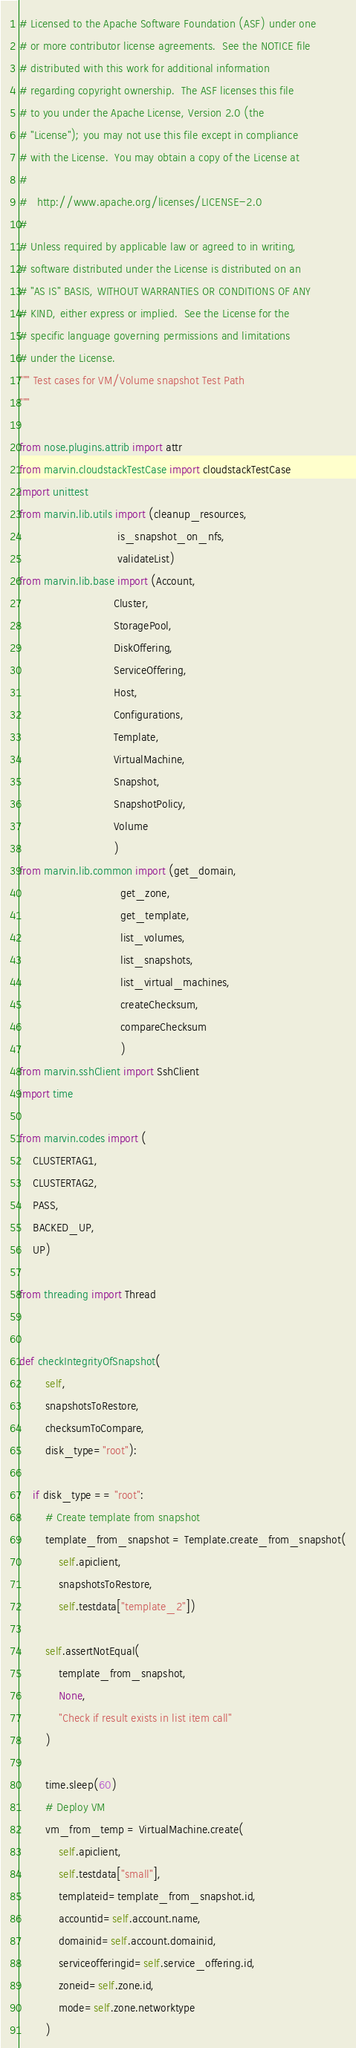<code> <loc_0><loc_0><loc_500><loc_500><_Python_># Licensed to the Apache Software Foundation (ASF) under one
# or more contributor license agreements.  See the NOTICE file
# distributed with this work for additional information
# regarding copyright ownership.  The ASF licenses this file
# to you under the Apache License, Version 2.0 (the
# "License"); you may not use this file except in compliance
# with the License.  You may obtain a copy of the License at
#
#   http://www.apache.org/licenses/LICENSE-2.0
#
# Unless required by applicable law or agreed to in writing,
# software distributed under the License is distributed on an
# "AS IS" BASIS, WITHOUT WARRANTIES OR CONDITIONS OF ANY
# KIND, either express or implied.  See the License for the
# specific language governing permissions and limitations
# under the License.
""" Test cases for VM/Volume snapshot Test Path
"""

from nose.plugins.attrib import attr
from marvin.cloudstackTestCase import cloudstackTestCase
import unittest
from marvin.lib.utils import (cleanup_resources,
                              is_snapshot_on_nfs,
                              validateList)
from marvin.lib.base import (Account,
                             Cluster,
                             StoragePool,
                             DiskOffering,
                             ServiceOffering,
                             Host,
                             Configurations,
                             Template,
                             VirtualMachine,
                             Snapshot,
                             SnapshotPolicy,
                             Volume
                             )
from marvin.lib.common import (get_domain,
                               get_zone,
                               get_template,
                               list_volumes,
                               list_snapshots,
                               list_virtual_machines,
                               createChecksum,
                               compareChecksum
                               )
from marvin.sshClient import SshClient
import time

from marvin.codes import (
    CLUSTERTAG1,
    CLUSTERTAG2,
    PASS,
    BACKED_UP,
    UP)

from threading import Thread


def checkIntegrityOfSnapshot(
        self,
        snapshotsToRestore,
        checksumToCompare,
        disk_type="root"):

    if disk_type == "root":
        # Create template from snapshot
        template_from_snapshot = Template.create_from_snapshot(
            self.apiclient,
            snapshotsToRestore,
            self.testdata["template_2"])

        self.assertNotEqual(
            template_from_snapshot,
            None,
            "Check if result exists in list item call"
        )

        time.sleep(60)
        # Deploy VM
        vm_from_temp = VirtualMachine.create(
            self.apiclient,
            self.testdata["small"],
            templateid=template_from_snapshot.id,
            accountid=self.account.name,
            domainid=self.account.domainid,
            serviceofferingid=self.service_offering.id,
            zoneid=self.zone.id,
            mode=self.zone.networktype
        )
</code> 